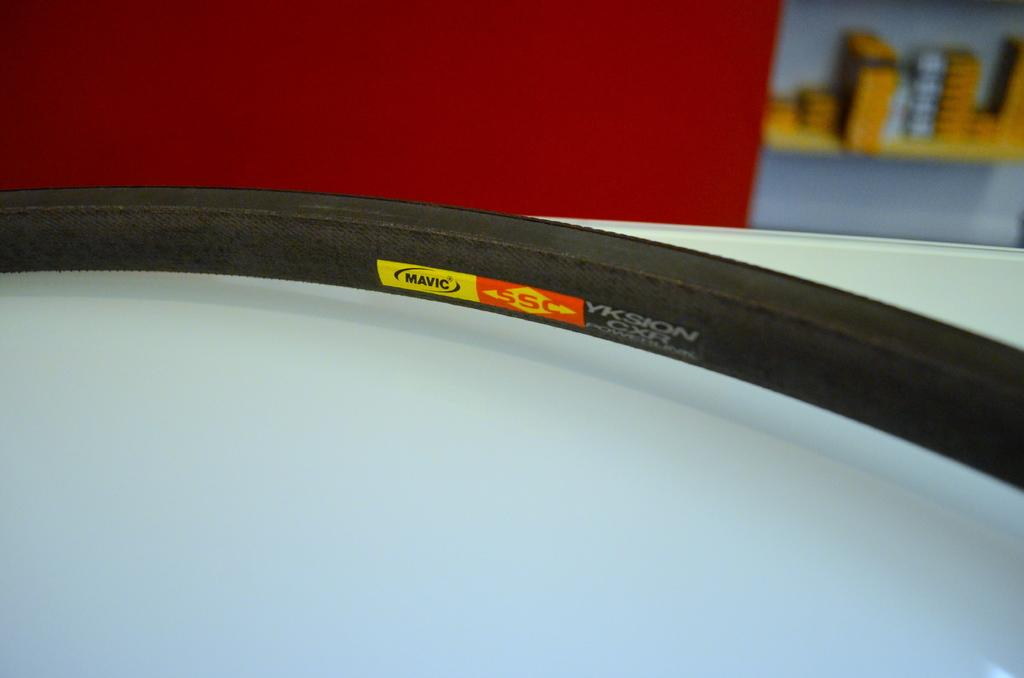What is the main object in the image? There is a tyre in the image. What is the color of the surface the tyre is on? The tyre is on a white surface. Can you describe the background of the image? There are objects in the background of the image. What type of poison is being applied to the tyre in the image? There is no poison or any indication of applying anything to the tyre in the image. 